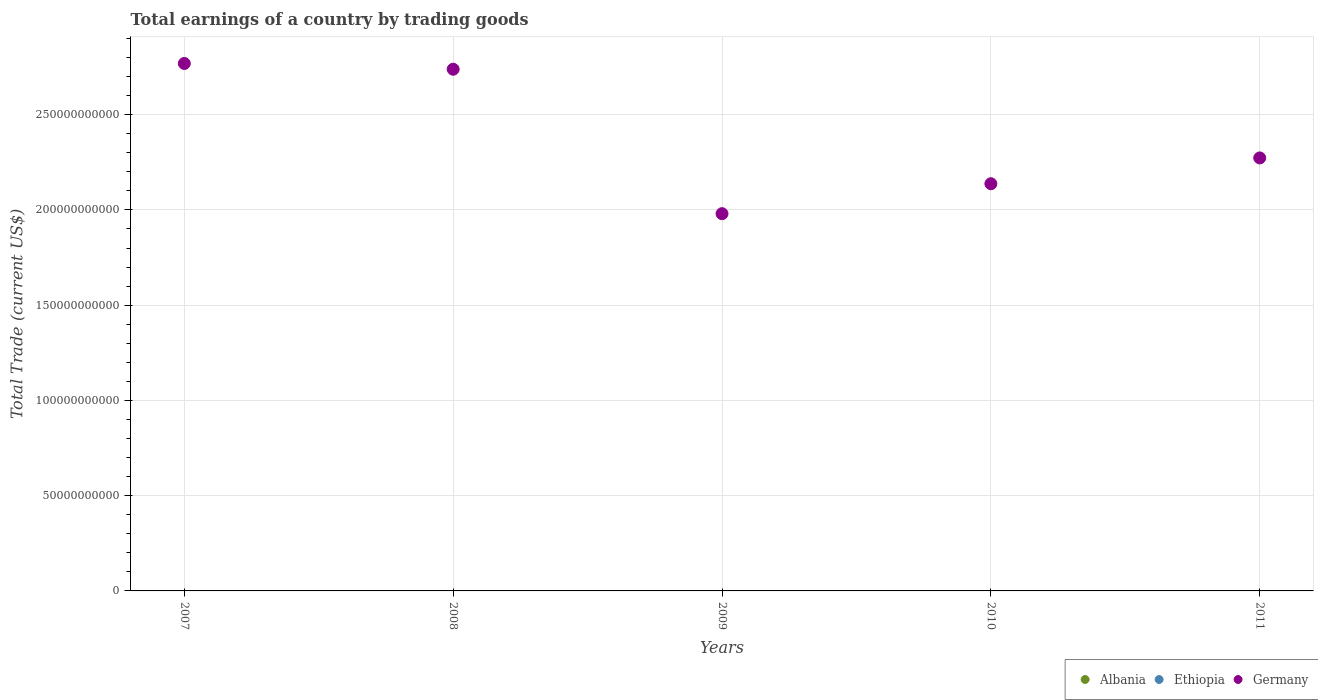Is the number of dotlines equal to the number of legend labels?
Offer a terse response. No. What is the total earnings in Ethiopia in 2011?
Make the answer very short. 0. Across all years, what is the maximum total earnings in Germany?
Offer a very short reply. 2.77e+11. Across all years, what is the minimum total earnings in Germany?
Keep it short and to the point. 1.98e+11. What is the total total earnings in Ethiopia in the graph?
Offer a very short reply. 0. What is the difference between the total earnings in Germany in 2007 and that in 2008?
Provide a short and direct response. 3.03e+09. What is the difference between the total earnings in Germany in 2011 and the total earnings in Albania in 2007?
Give a very brief answer. 2.27e+11. What is the average total earnings in Germany per year?
Ensure brevity in your answer.  2.38e+11. In how many years, is the total earnings in Albania greater than 160000000000 US$?
Make the answer very short. 0. What is the ratio of the total earnings in Germany in 2008 to that in 2009?
Your answer should be compact. 1.38. What is the difference between the highest and the second highest total earnings in Germany?
Provide a succinct answer. 3.03e+09. What is the difference between the highest and the lowest total earnings in Germany?
Ensure brevity in your answer.  7.88e+1. In how many years, is the total earnings in Albania greater than the average total earnings in Albania taken over all years?
Offer a terse response. 0. Is the sum of the total earnings in Germany in 2008 and 2009 greater than the maximum total earnings in Albania across all years?
Provide a short and direct response. Yes. Is it the case that in every year, the sum of the total earnings in Ethiopia and total earnings in Germany  is greater than the total earnings in Albania?
Provide a succinct answer. Yes. Does the total earnings in Ethiopia monotonically increase over the years?
Offer a very short reply. No. How many dotlines are there?
Provide a short and direct response. 1. Does the graph contain any zero values?
Offer a very short reply. Yes. Does the graph contain grids?
Keep it short and to the point. Yes. How are the legend labels stacked?
Offer a terse response. Horizontal. What is the title of the graph?
Your answer should be very brief. Total earnings of a country by trading goods. What is the label or title of the X-axis?
Provide a short and direct response. Years. What is the label or title of the Y-axis?
Your answer should be compact. Total Trade (current US$). What is the Total Trade (current US$) in Albania in 2007?
Your answer should be compact. 0. What is the Total Trade (current US$) of Ethiopia in 2007?
Your answer should be very brief. 0. What is the Total Trade (current US$) in Germany in 2007?
Make the answer very short. 2.77e+11. What is the Total Trade (current US$) in Germany in 2008?
Make the answer very short. 2.74e+11. What is the Total Trade (current US$) in Albania in 2009?
Offer a very short reply. 0. What is the Total Trade (current US$) of Ethiopia in 2009?
Offer a terse response. 0. What is the Total Trade (current US$) in Germany in 2009?
Ensure brevity in your answer.  1.98e+11. What is the Total Trade (current US$) of Ethiopia in 2010?
Make the answer very short. 0. What is the Total Trade (current US$) in Germany in 2010?
Make the answer very short. 2.14e+11. What is the Total Trade (current US$) in Albania in 2011?
Offer a terse response. 0. What is the Total Trade (current US$) of Germany in 2011?
Provide a succinct answer. 2.27e+11. Across all years, what is the maximum Total Trade (current US$) of Germany?
Offer a very short reply. 2.77e+11. Across all years, what is the minimum Total Trade (current US$) in Germany?
Ensure brevity in your answer.  1.98e+11. What is the total Total Trade (current US$) of Albania in the graph?
Provide a succinct answer. 0. What is the total Total Trade (current US$) in Ethiopia in the graph?
Your response must be concise. 0. What is the total Total Trade (current US$) of Germany in the graph?
Give a very brief answer. 1.19e+12. What is the difference between the Total Trade (current US$) in Germany in 2007 and that in 2008?
Your response must be concise. 3.03e+09. What is the difference between the Total Trade (current US$) in Germany in 2007 and that in 2009?
Offer a very short reply. 7.88e+1. What is the difference between the Total Trade (current US$) of Germany in 2007 and that in 2010?
Offer a very short reply. 6.31e+1. What is the difference between the Total Trade (current US$) of Germany in 2007 and that in 2011?
Make the answer very short. 4.96e+1. What is the difference between the Total Trade (current US$) in Germany in 2008 and that in 2009?
Offer a very short reply. 7.58e+1. What is the difference between the Total Trade (current US$) of Germany in 2008 and that in 2010?
Offer a very short reply. 6.01e+1. What is the difference between the Total Trade (current US$) of Germany in 2008 and that in 2011?
Your response must be concise. 4.65e+1. What is the difference between the Total Trade (current US$) of Germany in 2009 and that in 2010?
Ensure brevity in your answer.  -1.57e+1. What is the difference between the Total Trade (current US$) in Germany in 2009 and that in 2011?
Give a very brief answer. -2.93e+1. What is the difference between the Total Trade (current US$) of Germany in 2010 and that in 2011?
Make the answer very short. -1.35e+1. What is the average Total Trade (current US$) in Albania per year?
Your answer should be compact. 0. What is the average Total Trade (current US$) in Ethiopia per year?
Provide a succinct answer. 0. What is the average Total Trade (current US$) in Germany per year?
Offer a very short reply. 2.38e+11. What is the ratio of the Total Trade (current US$) of Germany in 2007 to that in 2008?
Make the answer very short. 1.01. What is the ratio of the Total Trade (current US$) in Germany in 2007 to that in 2009?
Keep it short and to the point. 1.4. What is the ratio of the Total Trade (current US$) of Germany in 2007 to that in 2010?
Provide a short and direct response. 1.3. What is the ratio of the Total Trade (current US$) of Germany in 2007 to that in 2011?
Your answer should be compact. 1.22. What is the ratio of the Total Trade (current US$) of Germany in 2008 to that in 2009?
Your answer should be compact. 1.38. What is the ratio of the Total Trade (current US$) in Germany in 2008 to that in 2010?
Make the answer very short. 1.28. What is the ratio of the Total Trade (current US$) of Germany in 2008 to that in 2011?
Your answer should be compact. 1.2. What is the ratio of the Total Trade (current US$) in Germany in 2009 to that in 2010?
Provide a short and direct response. 0.93. What is the ratio of the Total Trade (current US$) in Germany in 2009 to that in 2011?
Provide a short and direct response. 0.87. What is the ratio of the Total Trade (current US$) in Germany in 2010 to that in 2011?
Your answer should be very brief. 0.94. What is the difference between the highest and the second highest Total Trade (current US$) in Germany?
Provide a short and direct response. 3.03e+09. What is the difference between the highest and the lowest Total Trade (current US$) of Germany?
Your answer should be compact. 7.88e+1. 